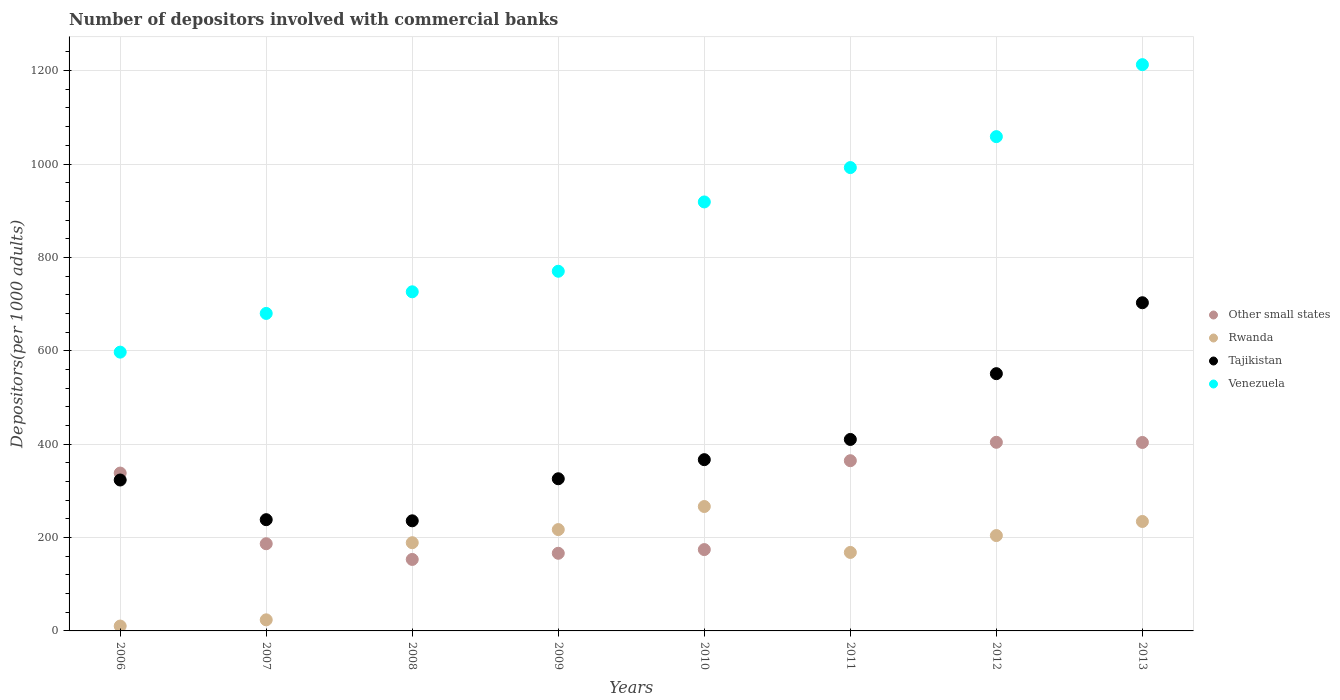Is the number of dotlines equal to the number of legend labels?
Your answer should be compact. Yes. What is the number of depositors involved with commercial banks in Tajikistan in 2009?
Ensure brevity in your answer.  325.89. Across all years, what is the maximum number of depositors involved with commercial banks in Tajikistan?
Give a very brief answer. 702.89. Across all years, what is the minimum number of depositors involved with commercial banks in Other small states?
Give a very brief answer. 153.11. In which year was the number of depositors involved with commercial banks in Venezuela maximum?
Give a very brief answer. 2013. In which year was the number of depositors involved with commercial banks in Venezuela minimum?
Your response must be concise. 2006. What is the total number of depositors involved with commercial banks in Other small states in the graph?
Make the answer very short. 2190.67. What is the difference between the number of depositors involved with commercial banks in Tajikistan in 2008 and that in 2010?
Make the answer very short. -130.97. What is the difference between the number of depositors involved with commercial banks in Other small states in 2010 and the number of depositors involved with commercial banks in Tajikistan in 2009?
Make the answer very short. -151.68. What is the average number of depositors involved with commercial banks in Other small states per year?
Give a very brief answer. 273.83. In the year 2013, what is the difference between the number of depositors involved with commercial banks in Rwanda and number of depositors involved with commercial banks in Venezuela?
Offer a very short reply. -978.43. In how many years, is the number of depositors involved with commercial banks in Other small states greater than 480?
Give a very brief answer. 0. What is the ratio of the number of depositors involved with commercial banks in Rwanda in 2006 to that in 2008?
Keep it short and to the point. 0.06. Is the number of depositors involved with commercial banks in Other small states in 2007 less than that in 2009?
Keep it short and to the point. No. Is the difference between the number of depositors involved with commercial banks in Rwanda in 2008 and 2012 greater than the difference between the number of depositors involved with commercial banks in Venezuela in 2008 and 2012?
Keep it short and to the point. Yes. What is the difference between the highest and the second highest number of depositors involved with commercial banks in Venezuela?
Your answer should be compact. 154.19. What is the difference between the highest and the lowest number of depositors involved with commercial banks in Other small states?
Make the answer very short. 250.91. In how many years, is the number of depositors involved with commercial banks in Other small states greater than the average number of depositors involved with commercial banks in Other small states taken over all years?
Offer a very short reply. 4. Is the sum of the number of depositors involved with commercial banks in Rwanda in 2009 and 2011 greater than the maximum number of depositors involved with commercial banks in Venezuela across all years?
Your response must be concise. No. Is it the case that in every year, the sum of the number of depositors involved with commercial banks in Rwanda and number of depositors involved with commercial banks in Other small states  is greater than the number of depositors involved with commercial banks in Venezuela?
Ensure brevity in your answer.  No. Is the number of depositors involved with commercial banks in Other small states strictly less than the number of depositors involved with commercial banks in Rwanda over the years?
Offer a very short reply. No. How many dotlines are there?
Provide a short and direct response. 4. Does the graph contain any zero values?
Offer a very short reply. No. Where does the legend appear in the graph?
Your response must be concise. Center right. How many legend labels are there?
Make the answer very short. 4. What is the title of the graph?
Your response must be concise. Number of depositors involved with commercial banks. Does "France" appear as one of the legend labels in the graph?
Your answer should be very brief. No. What is the label or title of the Y-axis?
Offer a very short reply. Depositors(per 1000 adults). What is the Depositors(per 1000 adults) in Other small states in 2006?
Offer a terse response. 338.08. What is the Depositors(per 1000 adults) in Rwanda in 2006?
Make the answer very short. 10.43. What is the Depositors(per 1000 adults) in Tajikistan in 2006?
Offer a terse response. 323.23. What is the Depositors(per 1000 adults) in Venezuela in 2006?
Provide a succinct answer. 597.09. What is the Depositors(per 1000 adults) in Other small states in 2007?
Provide a succinct answer. 186.74. What is the Depositors(per 1000 adults) in Rwanda in 2007?
Your answer should be very brief. 23.75. What is the Depositors(per 1000 adults) in Tajikistan in 2007?
Offer a terse response. 238.26. What is the Depositors(per 1000 adults) of Venezuela in 2007?
Your answer should be very brief. 679.99. What is the Depositors(per 1000 adults) in Other small states in 2008?
Your answer should be compact. 153.11. What is the Depositors(per 1000 adults) of Rwanda in 2008?
Give a very brief answer. 188.93. What is the Depositors(per 1000 adults) of Tajikistan in 2008?
Offer a terse response. 235.83. What is the Depositors(per 1000 adults) of Venezuela in 2008?
Provide a succinct answer. 726.32. What is the Depositors(per 1000 adults) in Other small states in 2009?
Your answer should be compact. 166.31. What is the Depositors(per 1000 adults) in Rwanda in 2009?
Provide a short and direct response. 217.05. What is the Depositors(per 1000 adults) of Tajikistan in 2009?
Offer a very short reply. 325.89. What is the Depositors(per 1000 adults) in Venezuela in 2009?
Give a very brief answer. 770.33. What is the Depositors(per 1000 adults) of Other small states in 2010?
Ensure brevity in your answer.  174.21. What is the Depositors(per 1000 adults) in Rwanda in 2010?
Your answer should be compact. 266.46. What is the Depositors(per 1000 adults) of Tajikistan in 2010?
Provide a succinct answer. 366.8. What is the Depositors(per 1000 adults) of Venezuela in 2010?
Provide a succinct answer. 918.79. What is the Depositors(per 1000 adults) in Other small states in 2011?
Your answer should be compact. 364.57. What is the Depositors(per 1000 adults) of Rwanda in 2011?
Provide a succinct answer. 168.11. What is the Depositors(per 1000 adults) of Tajikistan in 2011?
Offer a very short reply. 410.1. What is the Depositors(per 1000 adults) of Venezuela in 2011?
Keep it short and to the point. 992.39. What is the Depositors(per 1000 adults) of Other small states in 2012?
Ensure brevity in your answer.  404.02. What is the Depositors(per 1000 adults) of Rwanda in 2012?
Your answer should be compact. 204.22. What is the Depositors(per 1000 adults) in Tajikistan in 2012?
Provide a short and direct response. 550.99. What is the Depositors(per 1000 adults) of Venezuela in 2012?
Provide a succinct answer. 1058.65. What is the Depositors(per 1000 adults) in Other small states in 2013?
Your response must be concise. 403.64. What is the Depositors(per 1000 adults) in Rwanda in 2013?
Ensure brevity in your answer.  234.42. What is the Depositors(per 1000 adults) in Tajikistan in 2013?
Offer a very short reply. 702.89. What is the Depositors(per 1000 adults) in Venezuela in 2013?
Your response must be concise. 1212.85. Across all years, what is the maximum Depositors(per 1000 adults) in Other small states?
Your answer should be very brief. 404.02. Across all years, what is the maximum Depositors(per 1000 adults) of Rwanda?
Provide a short and direct response. 266.46. Across all years, what is the maximum Depositors(per 1000 adults) in Tajikistan?
Make the answer very short. 702.89. Across all years, what is the maximum Depositors(per 1000 adults) of Venezuela?
Give a very brief answer. 1212.85. Across all years, what is the minimum Depositors(per 1000 adults) in Other small states?
Keep it short and to the point. 153.11. Across all years, what is the minimum Depositors(per 1000 adults) in Rwanda?
Keep it short and to the point. 10.43. Across all years, what is the minimum Depositors(per 1000 adults) of Tajikistan?
Your response must be concise. 235.83. Across all years, what is the minimum Depositors(per 1000 adults) of Venezuela?
Keep it short and to the point. 597.09. What is the total Depositors(per 1000 adults) of Other small states in the graph?
Provide a short and direct response. 2190.67. What is the total Depositors(per 1000 adults) of Rwanda in the graph?
Your answer should be compact. 1313.36. What is the total Depositors(per 1000 adults) in Tajikistan in the graph?
Keep it short and to the point. 3153.99. What is the total Depositors(per 1000 adults) of Venezuela in the graph?
Provide a short and direct response. 6956.41. What is the difference between the Depositors(per 1000 adults) of Other small states in 2006 and that in 2007?
Your answer should be very brief. 151.33. What is the difference between the Depositors(per 1000 adults) of Rwanda in 2006 and that in 2007?
Your answer should be very brief. -13.32. What is the difference between the Depositors(per 1000 adults) in Tajikistan in 2006 and that in 2007?
Ensure brevity in your answer.  84.98. What is the difference between the Depositors(per 1000 adults) of Venezuela in 2006 and that in 2007?
Give a very brief answer. -82.9. What is the difference between the Depositors(per 1000 adults) of Other small states in 2006 and that in 2008?
Ensure brevity in your answer.  184.97. What is the difference between the Depositors(per 1000 adults) of Rwanda in 2006 and that in 2008?
Ensure brevity in your answer.  -178.5. What is the difference between the Depositors(per 1000 adults) of Tajikistan in 2006 and that in 2008?
Your answer should be very brief. 87.4. What is the difference between the Depositors(per 1000 adults) in Venezuela in 2006 and that in 2008?
Offer a very short reply. -129.23. What is the difference between the Depositors(per 1000 adults) of Other small states in 2006 and that in 2009?
Your answer should be compact. 171.77. What is the difference between the Depositors(per 1000 adults) in Rwanda in 2006 and that in 2009?
Make the answer very short. -206.62. What is the difference between the Depositors(per 1000 adults) in Tajikistan in 2006 and that in 2009?
Your answer should be very brief. -2.66. What is the difference between the Depositors(per 1000 adults) of Venezuela in 2006 and that in 2009?
Provide a short and direct response. -173.24. What is the difference between the Depositors(per 1000 adults) in Other small states in 2006 and that in 2010?
Give a very brief answer. 163.86. What is the difference between the Depositors(per 1000 adults) in Rwanda in 2006 and that in 2010?
Offer a very short reply. -256.03. What is the difference between the Depositors(per 1000 adults) of Tajikistan in 2006 and that in 2010?
Make the answer very short. -43.56. What is the difference between the Depositors(per 1000 adults) in Venezuela in 2006 and that in 2010?
Keep it short and to the point. -321.7. What is the difference between the Depositors(per 1000 adults) of Other small states in 2006 and that in 2011?
Provide a short and direct response. -26.49. What is the difference between the Depositors(per 1000 adults) of Rwanda in 2006 and that in 2011?
Your response must be concise. -157.68. What is the difference between the Depositors(per 1000 adults) of Tajikistan in 2006 and that in 2011?
Keep it short and to the point. -86.87. What is the difference between the Depositors(per 1000 adults) of Venezuela in 2006 and that in 2011?
Your response must be concise. -395.3. What is the difference between the Depositors(per 1000 adults) in Other small states in 2006 and that in 2012?
Provide a succinct answer. -65.94. What is the difference between the Depositors(per 1000 adults) in Rwanda in 2006 and that in 2012?
Your answer should be compact. -193.79. What is the difference between the Depositors(per 1000 adults) of Tajikistan in 2006 and that in 2012?
Your answer should be compact. -227.76. What is the difference between the Depositors(per 1000 adults) in Venezuela in 2006 and that in 2012?
Give a very brief answer. -461.56. What is the difference between the Depositors(per 1000 adults) in Other small states in 2006 and that in 2013?
Your answer should be compact. -65.56. What is the difference between the Depositors(per 1000 adults) of Rwanda in 2006 and that in 2013?
Your response must be concise. -223.99. What is the difference between the Depositors(per 1000 adults) in Tajikistan in 2006 and that in 2013?
Your answer should be compact. -379.66. What is the difference between the Depositors(per 1000 adults) in Venezuela in 2006 and that in 2013?
Your answer should be very brief. -615.75. What is the difference between the Depositors(per 1000 adults) of Other small states in 2007 and that in 2008?
Give a very brief answer. 33.63. What is the difference between the Depositors(per 1000 adults) in Rwanda in 2007 and that in 2008?
Provide a short and direct response. -165.19. What is the difference between the Depositors(per 1000 adults) of Tajikistan in 2007 and that in 2008?
Offer a terse response. 2.43. What is the difference between the Depositors(per 1000 adults) of Venezuela in 2007 and that in 2008?
Provide a succinct answer. -46.33. What is the difference between the Depositors(per 1000 adults) in Other small states in 2007 and that in 2009?
Give a very brief answer. 20.43. What is the difference between the Depositors(per 1000 adults) in Rwanda in 2007 and that in 2009?
Your answer should be very brief. -193.3. What is the difference between the Depositors(per 1000 adults) of Tajikistan in 2007 and that in 2009?
Offer a very short reply. -87.64. What is the difference between the Depositors(per 1000 adults) in Venezuela in 2007 and that in 2009?
Your answer should be compact. -90.34. What is the difference between the Depositors(per 1000 adults) in Other small states in 2007 and that in 2010?
Offer a terse response. 12.53. What is the difference between the Depositors(per 1000 adults) in Rwanda in 2007 and that in 2010?
Ensure brevity in your answer.  -242.71. What is the difference between the Depositors(per 1000 adults) in Tajikistan in 2007 and that in 2010?
Provide a short and direct response. -128.54. What is the difference between the Depositors(per 1000 adults) in Venezuela in 2007 and that in 2010?
Your response must be concise. -238.8. What is the difference between the Depositors(per 1000 adults) of Other small states in 2007 and that in 2011?
Provide a short and direct response. -177.83. What is the difference between the Depositors(per 1000 adults) in Rwanda in 2007 and that in 2011?
Provide a short and direct response. -144.36. What is the difference between the Depositors(per 1000 adults) in Tajikistan in 2007 and that in 2011?
Your answer should be very brief. -171.84. What is the difference between the Depositors(per 1000 adults) of Venezuela in 2007 and that in 2011?
Provide a short and direct response. -312.4. What is the difference between the Depositors(per 1000 adults) in Other small states in 2007 and that in 2012?
Your answer should be compact. -217.28. What is the difference between the Depositors(per 1000 adults) in Rwanda in 2007 and that in 2012?
Give a very brief answer. -180.47. What is the difference between the Depositors(per 1000 adults) in Tajikistan in 2007 and that in 2012?
Your answer should be compact. -312.74. What is the difference between the Depositors(per 1000 adults) of Venezuela in 2007 and that in 2012?
Give a very brief answer. -378.66. What is the difference between the Depositors(per 1000 adults) of Other small states in 2007 and that in 2013?
Make the answer very short. -216.9. What is the difference between the Depositors(per 1000 adults) of Rwanda in 2007 and that in 2013?
Your answer should be compact. -210.67. What is the difference between the Depositors(per 1000 adults) of Tajikistan in 2007 and that in 2013?
Give a very brief answer. -464.63. What is the difference between the Depositors(per 1000 adults) in Venezuela in 2007 and that in 2013?
Provide a short and direct response. -532.85. What is the difference between the Depositors(per 1000 adults) of Other small states in 2008 and that in 2009?
Make the answer very short. -13.2. What is the difference between the Depositors(per 1000 adults) in Rwanda in 2008 and that in 2009?
Provide a succinct answer. -28.11. What is the difference between the Depositors(per 1000 adults) of Tajikistan in 2008 and that in 2009?
Offer a terse response. -90.06. What is the difference between the Depositors(per 1000 adults) in Venezuela in 2008 and that in 2009?
Ensure brevity in your answer.  -44.02. What is the difference between the Depositors(per 1000 adults) in Other small states in 2008 and that in 2010?
Ensure brevity in your answer.  -21.11. What is the difference between the Depositors(per 1000 adults) in Rwanda in 2008 and that in 2010?
Offer a terse response. -77.52. What is the difference between the Depositors(per 1000 adults) in Tajikistan in 2008 and that in 2010?
Keep it short and to the point. -130.97. What is the difference between the Depositors(per 1000 adults) of Venezuela in 2008 and that in 2010?
Your answer should be compact. -192.47. What is the difference between the Depositors(per 1000 adults) of Other small states in 2008 and that in 2011?
Make the answer very short. -211.46. What is the difference between the Depositors(per 1000 adults) in Rwanda in 2008 and that in 2011?
Give a very brief answer. 20.82. What is the difference between the Depositors(per 1000 adults) of Tajikistan in 2008 and that in 2011?
Offer a very short reply. -174.27. What is the difference between the Depositors(per 1000 adults) of Venezuela in 2008 and that in 2011?
Your answer should be very brief. -266.07. What is the difference between the Depositors(per 1000 adults) of Other small states in 2008 and that in 2012?
Your response must be concise. -250.91. What is the difference between the Depositors(per 1000 adults) of Rwanda in 2008 and that in 2012?
Your answer should be compact. -15.28. What is the difference between the Depositors(per 1000 adults) in Tajikistan in 2008 and that in 2012?
Give a very brief answer. -315.16. What is the difference between the Depositors(per 1000 adults) in Venezuela in 2008 and that in 2012?
Give a very brief answer. -332.33. What is the difference between the Depositors(per 1000 adults) of Other small states in 2008 and that in 2013?
Provide a succinct answer. -250.53. What is the difference between the Depositors(per 1000 adults) of Rwanda in 2008 and that in 2013?
Your answer should be compact. -45.48. What is the difference between the Depositors(per 1000 adults) of Tajikistan in 2008 and that in 2013?
Give a very brief answer. -467.06. What is the difference between the Depositors(per 1000 adults) in Venezuela in 2008 and that in 2013?
Your response must be concise. -486.53. What is the difference between the Depositors(per 1000 adults) in Other small states in 2009 and that in 2010?
Provide a succinct answer. -7.91. What is the difference between the Depositors(per 1000 adults) in Rwanda in 2009 and that in 2010?
Provide a short and direct response. -49.41. What is the difference between the Depositors(per 1000 adults) of Tajikistan in 2009 and that in 2010?
Give a very brief answer. -40.9. What is the difference between the Depositors(per 1000 adults) in Venezuela in 2009 and that in 2010?
Provide a succinct answer. -148.45. What is the difference between the Depositors(per 1000 adults) of Other small states in 2009 and that in 2011?
Ensure brevity in your answer.  -198.26. What is the difference between the Depositors(per 1000 adults) in Rwanda in 2009 and that in 2011?
Give a very brief answer. 48.94. What is the difference between the Depositors(per 1000 adults) in Tajikistan in 2009 and that in 2011?
Offer a terse response. -84.21. What is the difference between the Depositors(per 1000 adults) in Venezuela in 2009 and that in 2011?
Your response must be concise. -222.05. What is the difference between the Depositors(per 1000 adults) in Other small states in 2009 and that in 2012?
Offer a terse response. -237.71. What is the difference between the Depositors(per 1000 adults) in Rwanda in 2009 and that in 2012?
Keep it short and to the point. 12.83. What is the difference between the Depositors(per 1000 adults) of Tajikistan in 2009 and that in 2012?
Ensure brevity in your answer.  -225.1. What is the difference between the Depositors(per 1000 adults) of Venezuela in 2009 and that in 2012?
Provide a succinct answer. -288.32. What is the difference between the Depositors(per 1000 adults) in Other small states in 2009 and that in 2013?
Provide a short and direct response. -237.33. What is the difference between the Depositors(per 1000 adults) of Rwanda in 2009 and that in 2013?
Provide a succinct answer. -17.37. What is the difference between the Depositors(per 1000 adults) in Tajikistan in 2009 and that in 2013?
Provide a short and direct response. -377. What is the difference between the Depositors(per 1000 adults) of Venezuela in 2009 and that in 2013?
Your answer should be very brief. -442.51. What is the difference between the Depositors(per 1000 adults) in Other small states in 2010 and that in 2011?
Give a very brief answer. -190.35. What is the difference between the Depositors(per 1000 adults) of Rwanda in 2010 and that in 2011?
Give a very brief answer. 98.35. What is the difference between the Depositors(per 1000 adults) in Tajikistan in 2010 and that in 2011?
Your answer should be compact. -43.3. What is the difference between the Depositors(per 1000 adults) in Venezuela in 2010 and that in 2011?
Provide a short and direct response. -73.6. What is the difference between the Depositors(per 1000 adults) of Other small states in 2010 and that in 2012?
Provide a succinct answer. -229.8. What is the difference between the Depositors(per 1000 adults) of Rwanda in 2010 and that in 2012?
Your answer should be compact. 62.24. What is the difference between the Depositors(per 1000 adults) of Tajikistan in 2010 and that in 2012?
Make the answer very short. -184.2. What is the difference between the Depositors(per 1000 adults) in Venezuela in 2010 and that in 2012?
Make the answer very short. -139.86. What is the difference between the Depositors(per 1000 adults) of Other small states in 2010 and that in 2013?
Provide a succinct answer. -229.42. What is the difference between the Depositors(per 1000 adults) of Rwanda in 2010 and that in 2013?
Offer a terse response. 32.04. What is the difference between the Depositors(per 1000 adults) of Tajikistan in 2010 and that in 2013?
Keep it short and to the point. -336.09. What is the difference between the Depositors(per 1000 adults) in Venezuela in 2010 and that in 2013?
Make the answer very short. -294.06. What is the difference between the Depositors(per 1000 adults) in Other small states in 2011 and that in 2012?
Provide a short and direct response. -39.45. What is the difference between the Depositors(per 1000 adults) in Rwanda in 2011 and that in 2012?
Provide a short and direct response. -36.1. What is the difference between the Depositors(per 1000 adults) in Tajikistan in 2011 and that in 2012?
Make the answer very short. -140.89. What is the difference between the Depositors(per 1000 adults) in Venezuela in 2011 and that in 2012?
Provide a short and direct response. -66.26. What is the difference between the Depositors(per 1000 adults) of Other small states in 2011 and that in 2013?
Provide a succinct answer. -39.07. What is the difference between the Depositors(per 1000 adults) of Rwanda in 2011 and that in 2013?
Offer a terse response. -66.31. What is the difference between the Depositors(per 1000 adults) of Tajikistan in 2011 and that in 2013?
Provide a succinct answer. -292.79. What is the difference between the Depositors(per 1000 adults) in Venezuela in 2011 and that in 2013?
Your answer should be compact. -220.46. What is the difference between the Depositors(per 1000 adults) in Other small states in 2012 and that in 2013?
Your answer should be very brief. 0.38. What is the difference between the Depositors(per 1000 adults) of Rwanda in 2012 and that in 2013?
Offer a terse response. -30.2. What is the difference between the Depositors(per 1000 adults) in Tajikistan in 2012 and that in 2013?
Offer a very short reply. -151.9. What is the difference between the Depositors(per 1000 adults) of Venezuela in 2012 and that in 2013?
Offer a terse response. -154.19. What is the difference between the Depositors(per 1000 adults) of Other small states in 2006 and the Depositors(per 1000 adults) of Rwanda in 2007?
Provide a succinct answer. 314.33. What is the difference between the Depositors(per 1000 adults) of Other small states in 2006 and the Depositors(per 1000 adults) of Tajikistan in 2007?
Your answer should be very brief. 99.82. What is the difference between the Depositors(per 1000 adults) in Other small states in 2006 and the Depositors(per 1000 adults) in Venezuela in 2007?
Offer a very short reply. -341.92. What is the difference between the Depositors(per 1000 adults) in Rwanda in 2006 and the Depositors(per 1000 adults) in Tajikistan in 2007?
Keep it short and to the point. -227.83. What is the difference between the Depositors(per 1000 adults) in Rwanda in 2006 and the Depositors(per 1000 adults) in Venezuela in 2007?
Offer a terse response. -669.56. What is the difference between the Depositors(per 1000 adults) in Tajikistan in 2006 and the Depositors(per 1000 adults) in Venezuela in 2007?
Your answer should be very brief. -356.76. What is the difference between the Depositors(per 1000 adults) in Other small states in 2006 and the Depositors(per 1000 adults) in Rwanda in 2008?
Offer a very short reply. 149.14. What is the difference between the Depositors(per 1000 adults) of Other small states in 2006 and the Depositors(per 1000 adults) of Tajikistan in 2008?
Keep it short and to the point. 102.25. What is the difference between the Depositors(per 1000 adults) of Other small states in 2006 and the Depositors(per 1000 adults) of Venezuela in 2008?
Offer a very short reply. -388.24. What is the difference between the Depositors(per 1000 adults) of Rwanda in 2006 and the Depositors(per 1000 adults) of Tajikistan in 2008?
Offer a terse response. -225.4. What is the difference between the Depositors(per 1000 adults) of Rwanda in 2006 and the Depositors(per 1000 adults) of Venezuela in 2008?
Ensure brevity in your answer.  -715.89. What is the difference between the Depositors(per 1000 adults) in Tajikistan in 2006 and the Depositors(per 1000 adults) in Venezuela in 2008?
Offer a very short reply. -403.09. What is the difference between the Depositors(per 1000 adults) of Other small states in 2006 and the Depositors(per 1000 adults) of Rwanda in 2009?
Provide a succinct answer. 121.03. What is the difference between the Depositors(per 1000 adults) in Other small states in 2006 and the Depositors(per 1000 adults) in Tajikistan in 2009?
Ensure brevity in your answer.  12.18. What is the difference between the Depositors(per 1000 adults) in Other small states in 2006 and the Depositors(per 1000 adults) in Venezuela in 2009?
Provide a succinct answer. -432.26. What is the difference between the Depositors(per 1000 adults) of Rwanda in 2006 and the Depositors(per 1000 adults) of Tajikistan in 2009?
Keep it short and to the point. -315.46. What is the difference between the Depositors(per 1000 adults) of Rwanda in 2006 and the Depositors(per 1000 adults) of Venezuela in 2009?
Ensure brevity in your answer.  -759.91. What is the difference between the Depositors(per 1000 adults) in Tajikistan in 2006 and the Depositors(per 1000 adults) in Venezuela in 2009?
Ensure brevity in your answer.  -447.1. What is the difference between the Depositors(per 1000 adults) in Other small states in 2006 and the Depositors(per 1000 adults) in Rwanda in 2010?
Offer a very short reply. 71.62. What is the difference between the Depositors(per 1000 adults) in Other small states in 2006 and the Depositors(per 1000 adults) in Tajikistan in 2010?
Offer a very short reply. -28.72. What is the difference between the Depositors(per 1000 adults) in Other small states in 2006 and the Depositors(per 1000 adults) in Venezuela in 2010?
Ensure brevity in your answer.  -580.71. What is the difference between the Depositors(per 1000 adults) of Rwanda in 2006 and the Depositors(per 1000 adults) of Tajikistan in 2010?
Provide a short and direct response. -356.37. What is the difference between the Depositors(per 1000 adults) of Rwanda in 2006 and the Depositors(per 1000 adults) of Venezuela in 2010?
Your answer should be compact. -908.36. What is the difference between the Depositors(per 1000 adults) of Tajikistan in 2006 and the Depositors(per 1000 adults) of Venezuela in 2010?
Ensure brevity in your answer.  -595.56. What is the difference between the Depositors(per 1000 adults) in Other small states in 2006 and the Depositors(per 1000 adults) in Rwanda in 2011?
Your answer should be compact. 169.97. What is the difference between the Depositors(per 1000 adults) of Other small states in 2006 and the Depositors(per 1000 adults) of Tajikistan in 2011?
Your answer should be very brief. -72.02. What is the difference between the Depositors(per 1000 adults) in Other small states in 2006 and the Depositors(per 1000 adults) in Venezuela in 2011?
Your answer should be very brief. -654.31. What is the difference between the Depositors(per 1000 adults) of Rwanda in 2006 and the Depositors(per 1000 adults) of Tajikistan in 2011?
Offer a terse response. -399.67. What is the difference between the Depositors(per 1000 adults) of Rwanda in 2006 and the Depositors(per 1000 adults) of Venezuela in 2011?
Give a very brief answer. -981.96. What is the difference between the Depositors(per 1000 adults) of Tajikistan in 2006 and the Depositors(per 1000 adults) of Venezuela in 2011?
Provide a succinct answer. -669.16. What is the difference between the Depositors(per 1000 adults) of Other small states in 2006 and the Depositors(per 1000 adults) of Rwanda in 2012?
Your response must be concise. 133.86. What is the difference between the Depositors(per 1000 adults) in Other small states in 2006 and the Depositors(per 1000 adults) in Tajikistan in 2012?
Offer a terse response. -212.92. What is the difference between the Depositors(per 1000 adults) in Other small states in 2006 and the Depositors(per 1000 adults) in Venezuela in 2012?
Ensure brevity in your answer.  -720.58. What is the difference between the Depositors(per 1000 adults) of Rwanda in 2006 and the Depositors(per 1000 adults) of Tajikistan in 2012?
Offer a terse response. -540.56. What is the difference between the Depositors(per 1000 adults) in Rwanda in 2006 and the Depositors(per 1000 adults) in Venezuela in 2012?
Make the answer very short. -1048.22. What is the difference between the Depositors(per 1000 adults) in Tajikistan in 2006 and the Depositors(per 1000 adults) in Venezuela in 2012?
Ensure brevity in your answer.  -735.42. What is the difference between the Depositors(per 1000 adults) of Other small states in 2006 and the Depositors(per 1000 adults) of Rwanda in 2013?
Your answer should be very brief. 103.66. What is the difference between the Depositors(per 1000 adults) in Other small states in 2006 and the Depositors(per 1000 adults) in Tajikistan in 2013?
Offer a terse response. -364.81. What is the difference between the Depositors(per 1000 adults) in Other small states in 2006 and the Depositors(per 1000 adults) in Venezuela in 2013?
Offer a terse response. -874.77. What is the difference between the Depositors(per 1000 adults) of Rwanda in 2006 and the Depositors(per 1000 adults) of Tajikistan in 2013?
Offer a very short reply. -692.46. What is the difference between the Depositors(per 1000 adults) of Rwanda in 2006 and the Depositors(per 1000 adults) of Venezuela in 2013?
Give a very brief answer. -1202.42. What is the difference between the Depositors(per 1000 adults) in Tajikistan in 2006 and the Depositors(per 1000 adults) in Venezuela in 2013?
Ensure brevity in your answer.  -889.61. What is the difference between the Depositors(per 1000 adults) of Other small states in 2007 and the Depositors(per 1000 adults) of Rwanda in 2008?
Your answer should be very brief. -2.19. What is the difference between the Depositors(per 1000 adults) of Other small states in 2007 and the Depositors(per 1000 adults) of Tajikistan in 2008?
Your answer should be compact. -49.09. What is the difference between the Depositors(per 1000 adults) in Other small states in 2007 and the Depositors(per 1000 adults) in Venezuela in 2008?
Give a very brief answer. -539.58. What is the difference between the Depositors(per 1000 adults) of Rwanda in 2007 and the Depositors(per 1000 adults) of Tajikistan in 2008?
Provide a short and direct response. -212.08. What is the difference between the Depositors(per 1000 adults) in Rwanda in 2007 and the Depositors(per 1000 adults) in Venezuela in 2008?
Your response must be concise. -702.57. What is the difference between the Depositors(per 1000 adults) of Tajikistan in 2007 and the Depositors(per 1000 adults) of Venezuela in 2008?
Provide a short and direct response. -488.06. What is the difference between the Depositors(per 1000 adults) of Other small states in 2007 and the Depositors(per 1000 adults) of Rwanda in 2009?
Your answer should be compact. -30.3. What is the difference between the Depositors(per 1000 adults) of Other small states in 2007 and the Depositors(per 1000 adults) of Tajikistan in 2009?
Provide a succinct answer. -139.15. What is the difference between the Depositors(per 1000 adults) of Other small states in 2007 and the Depositors(per 1000 adults) of Venezuela in 2009?
Make the answer very short. -583.59. What is the difference between the Depositors(per 1000 adults) of Rwanda in 2007 and the Depositors(per 1000 adults) of Tajikistan in 2009?
Offer a very short reply. -302.14. What is the difference between the Depositors(per 1000 adults) of Rwanda in 2007 and the Depositors(per 1000 adults) of Venezuela in 2009?
Offer a terse response. -746.59. What is the difference between the Depositors(per 1000 adults) of Tajikistan in 2007 and the Depositors(per 1000 adults) of Venezuela in 2009?
Your response must be concise. -532.08. What is the difference between the Depositors(per 1000 adults) in Other small states in 2007 and the Depositors(per 1000 adults) in Rwanda in 2010?
Your answer should be compact. -79.72. What is the difference between the Depositors(per 1000 adults) of Other small states in 2007 and the Depositors(per 1000 adults) of Tajikistan in 2010?
Your response must be concise. -180.06. What is the difference between the Depositors(per 1000 adults) in Other small states in 2007 and the Depositors(per 1000 adults) in Venezuela in 2010?
Offer a very short reply. -732.05. What is the difference between the Depositors(per 1000 adults) of Rwanda in 2007 and the Depositors(per 1000 adults) of Tajikistan in 2010?
Ensure brevity in your answer.  -343.05. What is the difference between the Depositors(per 1000 adults) of Rwanda in 2007 and the Depositors(per 1000 adults) of Venezuela in 2010?
Make the answer very short. -895.04. What is the difference between the Depositors(per 1000 adults) of Tajikistan in 2007 and the Depositors(per 1000 adults) of Venezuela in 2010?
Make the answer very short. -680.53. What is the difference between the Depositors(per 1000 adults) of Other small states in 2007 and the Depositors(per 1000 adults) of Rwanda in 2011?
Your answer should be compact. 18.63. What is the difference between the Depositors(per 1000 adults) in Other small states in 2007 and the Depositors(per 1000 adults) in Tajikistan in 2011?
Your response must be concise. -223.36. What is the difference between the Depositors(per 1000 adults) in Other small states in 2007 and the Depositors(per 1000 adults) in Venezuela in 2011?
Provide a succinct answer. -805.65. What is the difference between the Depositors(per 1000 adults) in Rwanda in 2007 and the Depositors(per 1000 adults) in Tajikistan in 2011?
Provide a succinct answer. -386.35. What is the difference between the Depositors(per 1000 adults) of Rwanda in 2007 and the Depositors(per 1000 adults) of Venezuela in 2011?
Keep it short and to the point. -968.64. What is the difference between the Depositors(per 1000 adults) of Tajikistan in 2007 and the Depositors(per 1000 adults) of Venezuela in 2011?
Your response must be concise. -754.13. What is the difference between the Depositors(per 1000 adults) in Other small states in 2007 and the Depositors(per 1000 adults) in Rwanda in 2012?
Provide a succinct answer. -17.47. What is the difference between the Depositors(per 1000 adults) of Other small states in 2007 and the Depositors(per 1000 adults) of Tajikistan in 2012?
Your answer should be compact. -364.25. What is the difference between the Depositors(per 1000 adults) of Other small states in 2007 and the Depositors(per 1000 adults) of Venezuela in 2012?
Your answer should be compact. -871.91. What is the difference between the Depositors(per 1000 adults) in Rwanda in 2007 and the Depositors(per 1000 adults) in Tajikistan in 2012?
Your response must be concise. -527.24. What is the difference between the Depositors(per 1000 adults) of Rwanda in 2007 and the Depositors(per 1000 adults) of Venezuela in 2012?
Offer a very short reply. -1034.9. What is the difference between the Depositors(per 1000 adults) in Tajikistan in 2007 and the Depositors(per 1000 adults) in Venezuela in 2012?
Provide a short and direct response. -820.39. What is the difference between the Depositors(per 1000 adults) in Other small states in 2007 and the Depositors(per 1000 adults) in Rwanda in 2013?
Your response must be concise. -47.68. What is the difference between the Depositors(per 1000 adults) of Other small states in 2007 and the Depositors(per 1000 adults) of Tajikistan in 2013?
Give a very brief answer. -516.15. What is the difference between the Depositors(per 1000 adults) in Other small states in 2007 and the Depositors(per 1000 adults) in Venezuela in 2013?
Provide a short and direct response. -1026.1. What is the difference between the Depositors(per 1000 adults) in Rwanda in 2007 and the Depositors(per 1000 adults) in Tajikistan in 2013?
Ensure brevity in your answer.  -679.14. What is the difference between the Depositors(per 1000 adults) in Rwanda in 2007 and the Depositors(per 1000 adults) in Venezuela in 2013?
Offer a terse response. -1189.1. What is the difference between the Depositors(per 1000 adults) in Tajikistan in 2007 and the Depositors(per 1000 adults) in Venezuela in 2013?
Ensure brevity in your answer.  -974.59. What is the difference between the Depositors(per 1000 adults) in Other small states in 2008 and the Depositors(per 1000 adults) in Rwanda in 2009?
Your response must be concise. -63.94. What is the difference between the Depositors(per 1000 adults) in Other small states in 2008 and the Depositors(per 1000 adults) in Tajikistan in 2009?
Provide a succinct answer. -172.79. What is the difference between the Depositors(per 1000 adults) of Other small states in 2008 and the Depositors(per 1000 adults) of Venezuela in 2009?
Offer a very short reply. -617.23. What is the difference between the Depositors(per 1000 adults) of Rwanda in 2008 and the Depositors(per 1000 adults) of Tajikistan in 2009?
Offer a very short reply. -136.96. What is the difference between the Depositors(per 1000 adults) of Rwanda in 2008 and the Depositors(per 1000 adults) of Venezuela in 2009?
Your answer should be compact. -581.4. What is the difference between the Depositors(per 1000 adults) in Tajikistan in 2008 and the Depositors(per 1000 adults) in Venezuela in 2009?
Make the answer very short. -534.51. What is the difference between the Depositors(per 1000 adults) of Other small states in 2008 and the Depositors(per 1000 adults) of Rwanda in 2010?
Provide a short and direct response. -113.35. What is the difference between the Depositors(per 1000 adults) in Other small states in 2008 and the Depositors(per 1000 adults) in Tajikistan in 2010?
Your response must be concise. -213.69. What is the difference between the Depositors(per 1000 adults) of Other small states in 2008 and the Depositors(per 1000 adults) of Venezuela in 2010?
Give a very brief answer. -765.68. What is the difference between the Depositors(per 1000 adults) of Rwanda in 2008 and the Depositors(per 1000 adults) of Tajikistan in 2010?
Your answer should be very brief. -177.86. What is the difference between the Depositors(per 1000 adults) of Rwanda in 2008 and the Depositors(per 1000 adults) of Venezuela in 2010?
Keep it short and to the point. -729.85. What is the difference between the Depositors(per 1000 adults) of Tajikistan in 2008 and the Depositors(per 1000 adults) of Venezuela in 2010?
Keep it short and to the point. -682.96. What is the difference between the Depositors(per 1000 adults) of Other small states in 2008 and the Depositors(per 1000 adults) of Rwanda in 2011?
Offer a terse response. -15. What is the difference between the Depositors(per 1000 adults) of Other small states in 2008 and the Depositors(per 1000 adults) of Tajikistan in 2011?
Make the answer very short. -256.99. What is the difference between the Depositors(per 1000 adults) in Other small states in 2008 and the Depositors(per 1000 adults) in Venezuela in 2011?
Offer a very short reply. -839.28. What is the difference between the Depositors(per 1000 adults) in Rwanda in 2008 and the Depositors(per 1000 adults) in Tajikistan in 2011?
Offer a terse response. -221.16. What is the difference between the Depositors(per 1000 adults) of Rwanda in 2008 and the Depositors(per 1000 adults) of Venezuela in 2011?
Your response must be concise. -803.45. What is the difference between the Depositors(per 1000 adults) of Tajikistan in 2008 and the Depositors(per 1000 adults) of Venezuela in 2011?
Offer a terse response. -756.56. What is the difference between the Depositors(per 1000 adults) of Other small states in 2008 and the Depositors(per 1000 adults) of Rwanda in 2012?
Your answer should be compact. -51.11. What is the difference between the Depositors(per 1000 adults) of Other small states in 2008 and the Depositors(per 1000 adults) of Tajikistan in 2012?
Make the answer very short. -397.89. What is the difference between the Depositors(per 1000 adults) of Other small states in 2008 and the Depositors(per 1000 adults) of Venezuela in 2012?
Your answer should be compact. -905.55. What is the difference between the Depositors(per 1000 adults) in Rwanda in 2008 and the Depositors(per 1000 adults) in Tajikistan in 2012?
Your answer should be very brief. -362.06. What is the difference between the Depositors(per 1000 adults) of Rwanda in 2008 and the Depositors(per 1000 adults) of Venezuela in 2012?
Ensure brevity in your answer.  -869.72. What is the difference between the Depositors(per 1000 adults) of Tajikistan in 2008 and the Depositors(per 1000 adults) of Venezuela in 2012?
Provide a succinct answer. -822.82. What is the difference between the Depositors(per 1000 adults) of Other small states in 2008 and the Depositors(per 1000 adults) of Rwanda in 2013?
Your answer should be very brief. -81.31. What is the difference between the Depositors(per 1000 adults) of Other small states in 2008 and the Depositors(per 1000 adults) of Tajikistan in 2013?
Your answer should be compact. -549.78. What is the difference between the Depositors(per 1000 adults) of Other small states in 2008 and the Depositors(per 1000 adults) of Venezuela in 2013?
Give a very brief answer. -1059.74. What is the difference between the Depositors(per 1000 adults) of Rwanda in 2008 and the Depositors(per 1000 adults) of Tajikistan in 2013?
Keep it short and to the point. -513.96. What is the difference between the Depositors(per 1000 adults) of Rwanda in 2008 and the Depositors(per 1000 adults) of Venezuela in 2013?
Offer a very short reply. -1023.91. What is the difference between the Depositors(per 1000 adults) in Tajikistan in 2008 and the Depositors(per 1000 adults) in Venezuela in 2013?
Make the answer very short. -977.02. What is the difference between the Depositors(per 1000 adults) in Other small states in 2009 and the Depositors(per 1000 adults) in Rwanda in 2010?
Provide a succinct answer. -100.15. What is the difference between the Depositors(per 1000 adults) of Other small states in 2009 and the Depositors(per 1000 adults) of Tajikistan in 2010?
Keep it short and to the point. -200.49. What is the difference between the Depositors(per 1000 adults) of Other small states in 2009 and the Depositors(per 1000 adults) of Venezuela in 2010?
Provide a succinct answer. -752.48. What is the difference between the Depositors(per 1000 adults) in Rwanda in 2009 and the Depositors(per 1000 adults) in Tajikistan in 2010?
Offer a very short reply. -149.75. What is the difference between the Depositors(per 1000 adults) in Rwanda in 2009 and the Depositors(per 1000 adults) in Venezuela in 2010?
Your answer should be compact. -701.74. What is the difference between the Depositors(per 1000 adults) of Tajikistan in 2009 and the Depositors(per 1000 adults) of Venezuela in 2010?
Your response must be concise. -592.9. What is the difference between the Depositors(per 1000 adults) of Other small states in 2009 and the Depositors(per 1000 adults) of Rwanda in 2011?
Offer a very short reply. -1.8. What is the difference between the Depositors(per 1000 adults) of Other small states in 2009 and the Depositors(per 1000 adults) of Tajikistan in 2011?
Provide a succinct answer. -243.79. What is the difference between the Depositors(per 1000 adults) in Other small states in 2009 and the Depositors(per 1000 adults) in Venezuela in 2011?
Your response must be concise. -826.08. What is the difference between the Depositors(per 1000 adults) of Rwanda in 2009 and the Depositors(per 1000 adults) of Tajikistan in 2011?
Provide a succinct answer. -193.05. What is the difference between the Depositors(per 1000 adults) of Rwanda in 2009 and the Depositors(per 1000 adults) of Venezuela in 2011?
Offer a very short reply. -775.34. What is the difference between the Depositors(per 1000 adults) in Tajikistan in 2009 and the Depositors(per 1000 adults) in Venezuela in 2011?
Offer a terse response. -666.5. What is the difference between the Depositors(per 1000 adults) in Other small states in 2009 and the Depositors(per 1000 adults) in Rwanda in 2012?
Ensure brevity in your answer.  -37.91. What is the difference between the Depositors(per 1000 adults) in Other small states in 2009 and the Depositors(per 1000 adults) in Tajikistan in 2012?
Make the answer very short. -384.69. What is the difference between the Depositors(per 1000 adults) in Other small states in 2009 and the Depositors(per 1000 adults) in Venezuela in 2012?
Your answer should be compact. -892.34. What is the difference between the Depositors(per 1000 adults) of Rwanda in 2009 and the Depositors(per 1000 adults) of Tajikistan in 2012?
Your answer should be very brief. -333.95. What is the difference between the Depositors(per 1000 adults) in Rwanda in 2009 and the Depositors(per 1000 adults) in Venezuela in 2012?
Your answer should be compact. -841.61. What is the difference between the Depositors(per 1000 adults) in Tajikistan in 2009 and the Depositors(per 1000 adults) in Venezuela in 2012?
Provide a succinct answer. -732.76. What is the difference between the Depositors(per 1000 adults) of Other small states in 2009 and the Depositors(per 1000 adults) of Rwanda in 2013?
Make the answer very short. -68.11. What is the difference between the Depositors(per 1000 adults) of Other small states in 2009 and the Depositors(per 1000 adults) of Tajikistan in 2013?
Offer a terse response. -536.58. What is the difference between the Depositors(per 1000 adults) of Other small states in 2009 and the Depositors(per 1000 adults) of Venezuela in 2013?
Give a very brief answer. -1046.54. What is the difference between the Depositors(per 1000 adults) of Rwanda in 2009 and the Depositors(per 1000 adults) of Tajikistan in 2013?
Your response must be concise. -485.84. What is the difference between the Depositors(per 1000 adults) of Rwanda in 2009 and the Depositors(per 1000 adults) of Venezuela in 2013?
Make the answer very short. -995.8. What is the difference between the Depositors(per 1000 adults) of Tajikistan in 2009 and the Depositors(per 1000 adults) of Venezuela in 2013?
Provide a succinct answer. -886.95. What is the difference between the Depositors(per 1000 adults) in Other small states in 2010 and the Depositors(per 1000 adults) in Rwanda in 2011?
Your answer should be compact. 6.1. What is the difference between the Depositors(per 1000 adults) of Other small states in 2010 and the Depositors(per 1000 adults) of Tajikistan in 2011?
Provide a short and direct response. -235.89. What is the difference between the Depositors(per 1000 adults) of Other small states in 2010 and the Depositors(per 1000 adults) of Venezuela in 2011?
Offer a very short reply. -818.17. What is the difference between the Depositors(per 1000 adults) in Rwanda in 2010 and the Depositors(per 1000 adults) in Tajikistan in 2011?
Offer a terse response. -143.64. What is the difference between the Depositors(per 1000 adults) of Rwanda in 2010 and the Depositors(per 1000 adults) of Venezuela in 2011?
Your response must be concise. -725.93. What is the difference between the Depositors(per 1000 adults) of Tajikistan in 2010 and the Depositors(per 1000 adults) of Venezuela in 2011?
Offer a very short reply. -625.59. What is the difference between the Depositors(per 1000 adults) in Other small states in 2010 and the Depositors(per 1000 adults) in Rwanda in 2012?
Keep it short and to the point. -30. What is the difference between the Depositors(per 1000 adults) in Other small states in 2010 and the Depositors(per 1000 adults) in Tajikistan in 2012?
Keep it short and to the point. -376.78. What is the difference between the Depositors(per 1000 adults) of Other small states in 2010 and the Depositors(per 1000 adults) of Venezuela in 2012?
Offer a very short reply. -884.44. What is the difference between the Depositors(per 1000 adults) in Rwanda in 2010 and the Depositors(per 1000 adults) in Tajikistan in 2012?
Offer a terse response. -284.54. What is the difference between the Depositors(per 1000 adults) of Rwanda in 2010 and the Depositors(per 1000 adults) of Venezuela in 2012?
Ensure brevity in your answer.  -792.2. What is the difference between the Depositors(per 1000 adults) in Tajikistan in 2010 and the Depositors(per 1000 adults) in Venezuela in 2012?
Your answer should be compact. -691.86. What is the difference between the Depositors(per 1000 adults) of Other small states in 2010 and the Depositors(per 1000 adults) of Rwanda in 2013?
Keep it short and to the point. -60.2. What is the difference between the Depositors(per 1000 adults) of Other small states in 2010 and the Depositors(per 1000 adults) of Tajikistan in 2013?
Offer a terse response. -528.68. What is the difference between the Depositors(per 1000 adults) in Other small states in 2010 and the Depositors(per 1000 adults) in Venezuela in 2013?
Provide a short and direct response. -1038.63. What is the difference between the Depositors(per 1000 adults) in Rwanda in 2010 and the Depositors(per 1000 adults) in Tajikistan in 2013?
Your response must be concise. -436.43. What is the difference between the Depositors(per 1000 adults) of Rwanda in 2010 and the Depositors(per 1000 adults) of Venezuela in 2013?
Provide a succinct answer. -946.39. What is the difference between the Depositors(per 1000 adults) of Tajikistan in 2010 and the Depositors(per 1000 adults) of Venezuela in 2013?
Provide a short and direct response. -846.05. What is the difference between the Depositors(per 1000 adults) of Other small states in 2011 and the Depositors(per 1000 adults) of Rwanda in 2012?
Ensure brevity in your answer.  160.35. What is the difference between the Depositors(per 1000 adults) of Other small states in 2011 and the Depositors(per 1000 adults) of Tajikistan in 2012?
Your answer should be compact. -186.42. What is the difference between the Depositors(per 1000 adults) of Other small states in 2011 and the Depositors(per 1000 adults) of Venezuela in 2012?
Ensure brevity in your answer.  -694.08. What is the difference between the Depositors(per 1000 adults) of Rwanda in 2011 and the Depositors(per 1000 adults) of Tajikistan in 2012?
Provide a succinct answer. -382.88. What is the difference between the Depositors(per 1000 adults) in Rwanda in 2011 and the Depositors(per 1000 adults) in Venezuela in 2012?
Make the answer very short. -890.54. What is the difference between the Depositors(per 1000 adults) in Tajikistan in 2011 and the Depositors(per 1000 adults) in Venezuela in 2012?
Make the answer very short. -648.55. What is the difference between the Depositors(per 1000 adults) of Other small states in 2011 and the Depositors(per 1000 adults) of Rwanda in 2013?
Give a very brief answer. 130.15. What is the difference between the Depositors(per 1000 adults) in Other small states in 2011 and the Depositors(per 1000 adults) in Tajikistan in 2013?
Ensure brevity in your answer.  -338.32. What is the difference between the Depositors(per 1000 adults) in Other small states in 2011 and the Depositors(per 1000 adults) in Venezuela in 2013?
Your response must be concise. -848.28. What is the difference between the Depositors(per 1000 adults) in Rwanda in 2011 and the Depositors(per 1000 adults) in Tajikistan in 2013?
Provide a short and direct response. -534.78. What is the difference between the Depositors(per 1000 adults) in Rwanda in 2011 and the Depositors(per 1000 adults) in Venezuela in 2013?
Give a very brief answer. -1044.73. What is the difference between the Depositors(per 1000 adults) of Tajikistan in 2011 and the Depositors(per 1000 adults) of Venezuela in 2013?
Provide a short and direct response. -802.75. What is the difference between the Depositors(per 1000 adults) in Other small states in 2012 and the Depositors(per 1000 adults) in Rwanda in 2013?
Offer a very short reply. 169.6. What is the difference between the Depositors(per 1000 adults) in Other small states in 2012 and the Depositors(per 1000 adults) in Tajikistan in 2013?
Provide a succinct answer. -298.87. What is the difference between the Depositors(per 1000 adults) in Other small states in 2012 and the Depositors(per 1000 adults) in Venezuela in 2013?
Make the answer very short. -808.83. What is the difference between the Depositors(per 1000 adults) of Rwanda in 2012 and the Depositors(per 1000 adults) of Tajikistan in 2013?
Ensure brevity in your answer.  -498.67. What is the difference between the Depositors(per 1000 adults) of Rwanda in 2012 and the Depositors(per 1000 adults) of Venezuela in 2013?
Provide a short and direct response. -1008.63. What is the difference between the Depositors(per 1000 adults) in Tajikistan in 2012 and the Depositors(per 1000 adults) in Venezuela in 2013?
Your response must be concise. -661.85. What is the average Depositors(per 1000 adults) in Other small states per year?
Ensure brevity in your answer.  273.83. What is the average Depositors(per 1000 adults) in Rwanda per year?
Your answer should be compact. 164.17. What is the average Depositors(per 1000 adults) in Tajikistan per year?
Keep it short and to the point. 394.25. What is the average Depositors(per 1000 adults) in Venezuela per year?
Make the answer very short. 869.55. In the year 2006, what is the difference between the Depositors(per 1000 adults) of Other small states and Depositors(per 1000 adults) of Rwanda?
Your answer should be very brief. 327.65. In the year 2006, what is the difference between the Depositors(per 1000 adults) of Other small states and Depositors(per 1000 adults) of Tajikistan?
Provide a succinct answer. 14.84. In the year 2006, what is the difference between the Depositors(per 1000 adults) in Other small states and Depositors(per 1000 adults) in Venezuela?
Provide a succinct answer. -259.02. In the year 2006, what is the difference between the Depositors(per 1000 adults) in Rwanda and Depositors(per 1000 adults) in Tajikistan?
Provide a short and direct response. -312.8. In the year 2006, what is the difference between the Depositors(per 1000 adults) of Rwanda and Depositors(per 1000 adults) of Venezuela?
Your response must be concise. -586.66. In the year 2006, what is the difference between the Depositors(per 1000 adults) in Tajikistan and Depositors(per 1000 adults) in Venezuela?
Keep it short and to the point. -273.86. In the year 2007, what is the difference between the Depositors(per 1000 adults) in Other small states and Depositors(per 1000 adults) in Rwanda?
Offer a terse response. 162.99. In the year 2007, what is the difference between the Depositors(per 1000 adults) in Other small states and Depositors(per 1000 adults) in Tajikistan?
Provide a short and direct response. -51.52. In the year 2007, what is the difference between the Depositors(per 1000 adults) in Other small states and Depositors(per 1000 adults) in Venezuela?
Keep it short and to the point. -493.25. In the year 2007, what is the difference between the Depositors(per 1000 adults) in Rwanda and Depositors(per 1000 adults) in Tajikistan?
Offer a very short reply. -214.51. In the year 2007, what is the difference between the Depositors(per 1000 adults) in Rwanda and Depositors(per 1000 adults) in Venezuela?
Your answer should be very brief. -656.24. In the year 2007, what is the difference between the Depositors(per 1000 adults) of Tajikistan and Depositors(per 1000 adults) of Venezuela?
Provide a succinct answer. -441.73. In the year 2008, what is the difference between the Depositors(per 1000 adults) of Other small states and Depositors(per 1000 adults) of Rwanda?
Ensure brevity in your answer.  -35.83. In the year 2008, what is the difference between the Depositors(per 1000 adults) in Other small states and Depositors(per 1000 adults) in Tajikistan?
Offer a terse response. -82.72. In the year 2008, what is the difference between the Depositors(per 1000 adults) of Other small states and Depositors(per 1000 adults) of Venezuela?
Your answer should be very brief. -573.21. In the year 2008, what is the difference between the Depositors(per 1000 adults) of Rwanda and Depositors(per 1000 adults) of Tajikistan?
Keep it short and to the point. -46.89. In the year 2008, what is the difference between the Depositors(per 1000 adults) of Rwanda and Depositors(per 1000 adults) of Venezuela?
Give a very brief answer. -537.38. In the year 2008, what is the difference between the Depositors(per 1000 adults) in Tajikistan and Depositors(per 1000 adults) in Venezuela?
Ensure brevity in your answer.  -490.49. In the year 2009, what is the difference between the Depositors(per 1000 adults) in Other small states and Depositors(per 1000 adults) in Rwanda?
Provide a succinct answer. -50.74. In the year 2009, what is the difference between the Depositors(per 1000 adults) of Other small states and Depositors(per 1000 adults) of Tajikistan?
Your answer should be compact. -159.59. In the year 2009, what is the difference between the Depositors(per 1000 adults) of Other small states and Depositors(per 1000 adults) of Venezuela?
Provide a short and direct response. -604.03. In the year 2009, what is the difference between the Depositors(per 1000 adults) in Rwanda and Depositors(per 1000 adults) in Tajikistan?
Your answer should be very brief. -108.85. In the year 2009, what is the difference between the Depositors(per 1000 adults) of Rwanda and Depositors(per 1000 adults) of Venezuela?
Your answer should be compact. -553.29. In the year 2009, what is the difference between the Depositors(per 1000 adults) of Tajikistan and Depositors(per 1000 adults) of Venezuela?
Your answer should be compact. -444.44. In the year 2010, what is the difference between the Depositors(per 1000 adults) of Other small states and Depositors(per 1000 adults) of Rwanda?
Ensure brevity in your answer.  -92.24. In the year 2010, what is the difference between the Depositors(per 1000 adults) in Other small states and Depositors(per 1000 adults) in Tajikistan?
Offer a very short reply. -192.58. In the year 2010, what is the difference between the Depositors(per 1000 adults) of Other small states and Depositors(per 1000 adults) of Venezuela?
Your response must be concise. -744.58. In the year 2010, what is the difference between the Depositors(per 1000 adults) of Rwanda and Depositors(per 1000 adults) of Tajikistan?
Your answer should be very brief. -100.34. In the year 2010, what is the difference between the Depositors(per 1000 adults) in Rwanda and Depositors(per 1000 adults) in Venezuela?
Make the answer very short. -652.33. In the year 2010, what is the difference between the Depositors(per 1000 adults) in Tajikistan and Depositors(per 1000 adults) in Venezuela?
Your answer should be compact. -551.99. In the year 2011, what is the difference between the Depositors(per 1000 adults) in Other small states and Depositors(per 1000 adults) in Rwanda?
Offer a terse response. 196.46. In the year 2011, what is the difference between the Depositors(per 1000 adults) of Other small states and Depositors(per 1000 adults) of Tajikistan?
Provide a short and direct response. -45.53. In the year 2011, what is the difference between the Depositors(per 1000 adults) of Other small states and Depositors(per 1000 adults) of Venezuela?
Your response must be concise. -627.82. In the year 2011, what is the difference between the Depositors(per 1000 adults) in Rwanda and Depositors(per 1000 adults) in Tajikistan?
Your answer should be very brief. -241.99. In the year 2011, what is the difference between the Depositors(per 1000 adults) of Rwanda and Depositors(per 1000 adults) of Venezuela?
Your answer should be compact. -824.28. In the year 2011, what is the difference between the Depositors(per 1000 adults) of Tajikistan and Depositors(per 1000 adults) of Venezuela?
Your response must be concise. -582.29. In the year 2012, what is the difference between the Depositors(per 1000 adults) of Other small states and Depositors(per 1000 adults) of Rwanda?
Give a very brief answer. 199.8. In the year 2012, what is the difference between the Depositors(per 1000 adults) of Other small states and Depositors(per 1000 adults) of Tajikistan?
Ensure brevity in your answer.  -146.98. In the year 2012, what is the difference between the Depositors(per 1000 adults) in Other small states and Depositors(per 1000 adults) in Venezuela?
Offer a terse response. -654.63. In the year 2012, what is the difference between the Depositors(per 1000 adults) of Rwanda and Depositors(per 1000 adults) of Tajikistan?
Keep it short and to the point. -346.78. In the year 2012, what is the difference between the Depositors(per 1000 adults) in Rwanda and Depositors(per 1000 adults) in Venezuela?
Your answer should be very brief. -854.44. In the year 2012, what is the difference between the Depositors(per 1000 adults) in Tajikistan and Depositors(per 1000 adults) in Venezuela?
Give a very brief answer. -507.66. In the year 2013, what is the difference between the Depositors(per 1000 adults) of Other small states and Depositors(per 1000 adults) of Rwanda?
Provide a succinct answer. 169.22. In the year 2013, what is the difference between the Depositors(per 1000 adults) in Other small states and Depositors(per 1000 adults) in Tajikistan?
Ensure brevity in your answer.  -299.25. In the year 2013, what is the difference between the Depositors(per 1000 adults) of Other small states and Depositors(per 1000 adults) of Venezuela?
Make the answer very short. -809.21. In the year 2013, what is the difference between the Depositors(per 1000 adults) in Rwanda and Depositors(per 1000 adults) in Tajikistan?
Your answer should be very brief. -468.47. In the year 2013, what is the difference between the Depositors(per 1000 adults) of Rwanda and Depositors(per 1000 adults) of Venezuela?
Provide a short and direct response. -978.43. In the year 2013, what is the difference between the Depositors(per 1000 adults) of Tajikistan and Depositors(per 1000 adults) of Venezuela?
Keep it short and to the point. -509.96. What is the ratio of the Depositors(per 1000 adults) in Other small states in 2006 to that in 2007?
Ensure brevity in your answer.  1.81. What is the ratio of the Depositors(per 1000 adults) of Rwanda in 2006 to that in 2007?
Offer a terse response. 0.44. What is the ratio of the Depositors(per 1000 adults) in Tajikistan in 2006 to that in 2007?
Provide a short and direct response. 1.36. What is the ratio of the Depositors(per 1000 adults) in Venezuela in 2006 to that in 2007?
Keep it short and to the point. 0.88. What is the ratio of the Depositors(per 1000 adults) of Other small states in 2006 to that in 2008?
Offer a terse response. 2.21. What is the ratio of the Depositors(per 1000 adults) of Rwanda in 2006 to that in 2008?
Your answer should be very brief. 0.06. What is the ratio of the Depositors(per 1000 adults) in Tajikistan in 2006 to that in 2008?
Your answer should be compact. 1.37. What is the ratio of the Depositors(per 1000 adults) in Venezuela in 2006 to that in 2008?
Offer a very short reply. 0.82. What is the ratio of the Depositors(per 1000 adults) in Other small states in 2006 to that in 2009?
Ensure brevity in your answer.  2.03. What is the ratio of the Depositors(per 1000 adults) of Rwanda in 2006 to that in 2009?
Keep it short and to the point. 0.05. What is the ratio of the Depositors(per 1000 adults) of Tajikistan in 2006 to that in 2009?
Offer a terse response. 0.99. What is the ratio of the Depositors(per 1000 adults) in Venezuela in 2006 to that in 2009?
Your response must be concise. 0.78. What is the ratio of the Depositors(per 1000 adults) in Other small states in 2006 to that in 2010?
Provide a short and direct response. 1.94. What is the ratio of the Depositors(per 1000 adults) of Rwanda in 2006 to that in 2010?
Your answer should be very brief. 0.04. What is the ratio of the Depositors(per 1000 adults) of Tajikistan in 2006 to that in 2010?
Offer a very short reply. 0.88. What is the ratio of the Depositors(per 1000 adults) of Venezuela in 2006 to that in 2010?
Your answer should be compact. 0.65. What is the ratio of the Depositors(per 1000 adults) in Other small states in 2006 to that in 2011?
Offer a very short reply. 0.93. What is the ratio of the Depositors(per 1000 adults) of Rwanda in 2006 to that in 2011?
Offer a very short reply. 0.06. What is the ratio of the Depositors(per 1000 adults) in Tajikistan in 2006 to that in 2011?
Provide a short and direct response. 0.79. What is the ratio of the Depositors(per 1000 adults) in Venezuela in 2006 to that in 2011?
Offer a terse response. 0.6. What is the ratio of the Depositors(per 1000 adults) in Other small states in 2006 to that in 2012?
Offer a terse response. 0.84. What is the ratio of the Depositors(per 1000 adults) in Rwanda in 2006 to that in 2012?
Provide a succinct answer. 0.05. What is the ratio of the Depositors(per 1000 adults) of Tajikistan in 2006 to that in 2012?
Offer a terse response. 0.59. What is the ratio of the Depositors(per 1000 adults) in Venezuela in 2006 to that in 2012?
Make the answer very short. 0.56. What is the ratio of the Depositors(per 1000 adults) of Other small states in 2006 to that in 2013?
Your answer should be very brief. 0.84. What is the ratio of the Depositors(per 1000 adults) in Rwanda in 2006 to that in 2013?
Offer a very short reply. 0.04. What is the ratio of the Depositors(per 1000 adults) in Tajikistan in 2006 to that in 2013?
Your answer should be very brief. 0.46. What is the ratio of the Depositors(per 1000 adults) of Venezuela in 2006 to that in 2013?
Your answer should be compact. 0.49. What is the ratio of the Depositors(per 1000 adults) in Other small states in 2007 to that in 2008?
Ensure brevity in your answer.  1.22. What is the ratio of the Depositors(per 1000 adults) of Rwanda in 2007 to that in 2008?
Make the answer very short. 0.13. What is the ratio of the Depositors(per 1000 adults) of Tajikistan in 2007 to that in 2008?
Your answer should be very brief. 1.01. What is the ratio of the Depositors(per 1000 adults) of Venezuela in 2007 to that in 2008?
Ensure brevity in your answer.  0.94. What is the ratio of the Depositors(per 1000 adults) in Other small states in 2007 to that in 2009?
Your answer should be very brief. 1.12. What is the ratio of the Depositors(per 1000 adults) in Rwanda in 2007 to that in 2009?
Offer a terse response. 0.11. What is the ratio of the Depositors(per 1000 adults) of Tajikistan in 2007 to that in 2009?
Your response must be concise. 0.73. What is the ratio of the Depositors(per 1000 adults) in Venezuela in 2007 to that in 2009?
Keep it short and to the point. 0.88. What is the ratio of the Depositors(per 1000 adults) of Other small states in 2007 to that in 2010?
Provide a short and direct response. 1.07. What is the ratio of the Depositors(per 1000 adults) of Rwanda in 2007 to that in 2010?
Make the answer very short. 0.09. What is the ratio of the Depositors(per 1000 adults) of Tajikistan in 2007 to that in 2010?
Provide a short and direct response. 0.65. What is the ratio of the Depositors(per 1000 adults) in Venezuela in 2007 to that in 2010?
Offer a very short reply. 0.74. What is the ratio of the Depositors(per 1000 adults) of Other small states in 2007 to that in 2011?
Provide a succinct answer. 0.51. What is the ratio of the Depositors(per 1000 adults) in Rwanda in 2007 to that in 2011?
Provide a short and direct response. 0.14. What is the ratio of the Depositors(per 1000 adults) of Tajikistan in 2007 to that in 2011?
Provide a succinct answer. 0.58. What is the ratio of the Depositors(per 1000 adults) of Venezuela in 2007 to that in 2011?
Ensure brevity in your answer.  0.69. What is the ratio of the Depositors(per 1000 adults) in Other small states in 2007 to that in 2012?
Offer a terse response. 0.46. What is the ratio of the Depositors(per 1000 adults) in Rwanda in 2007 to that in 2012?
Provide a succinct answer. 0.12. What is the ratio of the Depositors(per 1000 adults) in Tajikistan in 2007 to that in 2012?
Provide a succinct answer. 0.43. What is the ratio of the Depositors(per 1000 adults) of Venezuela in 2007 to that in 2012?
Your answer should be very brief. 0.64. What is the ratio of the Depositors(per 1000 adults) of Other small states in 2007 to that in 2013?
Your answer should be compact. 0.46. What is the ratio of the Depositors(per 1000 adults) in Rwanda in 2007 to that in 2013?
Provide a succinct answer. 0.1. What is the ratio of the Depositors(per 1000 adults) of Tajikistan in 2007 to that in 2013?
Offer a terse response. 0.34. What is the ratio of the Depositors(per 1000 adults) in Venezuela in 2007 to that in 2013?
Your answer should be compact. 0.56. What is the ratio of the Depositors(per 1000 adults) in Other small states in 2008 to that in 2009?
Make the answer very short. 0.92. What is the ratio of the Depositors(per 1000 adults) of Rwanda in 2008 to that in 2009?
Make the answer very short. 0.87. What is the ratio of the Depositors(per 1000 adults) in Tajikistan in 2008 to that in 2009?
Provide a short and direct response. 0.72. What is the ratio of the Depositors(per 1000 adults) of Venezuela in 2008 to that in 2009?
Keep it short and to the point. 0.94. What is the ratio of the Depositors(per 1000 adults) in Other small states in 2008 to that in 2010?
Provide a short and direct response. 0.88. What is the ratio of the Depositors(per 1000 adults) in Rwanda in 2008 to that in 2010?
Your response must be concise. 0.71. What is the ratio of the Depositors(per 1000 adults) in Tajikistan in 2008 to that in 2010?
Provide a succinct answer. 0.64. What is the ratio of the Depositors(per 1000 adults) of Venezuela in 2008 to that in 2010?
Make the answer very short. 0.79. What is the ratio of the Depositors(per 1000 adults) of Other small states in 2008 to that in 2011?
Your answer should be compact. 0.42. What is the ratio of the Depositors(per 1000 adults) in Rwanda in 2008 to that in 2011?
Make the answer very short. 1.12. What is the ratio of the Depositors(per 1000 adults) of Tajikistan in 2008 to that in 2011?
Provide a succinct answer. 0.57. What is the ratio of the Depositors(per 1000 adults) in Venezuela in 2008 to that in 2011?
Your answer should be compact. 0.73. What is the ratio of the Depositors(per 1000 adults) of Other small states in 2008 to that in 2012?
Keep it short and to the point. 0.38. What is the ratio of the Depositors(per 1000 adults) of Rwanda in 2008 to that in 2012?
Keep it short and to the point. 0.93. What is the ratio of the Depositors(per 1000 adults) of Tajikistan in 2008 to that in 2012?
Make the answer very short. 0.43. What is the ratio of the Depositors(per 1000 adults) in Venezuela in 2008 to that in 2012?
Make the answer very short. 0.69. What is the ratio of the Depositors(per 1000 adults) in Other small states in 2008 to that in 2013?
Ensure brevity in your answer.  0.38. What is the ratio of the Depositors(per 1000 adults) in Rwanda in 2008 to that in 2013?
Your answer should be compact. 0.81. What is the ratio of the Depositors(per 1000 adults) in Tajikistan in 2008 to that in 2013?
Offer a terse response. 0.34. What is the ratio of the Depositors(per 1000 adults) in Venezuela in 2008 to that in 2013?
Provide a short and direct response. 0.6. What is the ratio of the Depositors(per 1000 adults) in Other small states in 2009 to that in 2010?
Make the answer very short. 0.95. What is the ratio of the Depositors(per 1000 adults) of Rwanda in 2009 to that in 2010?
Provide a succinct answer. 0.81. What is the ratio of the Depositors(per 1000 adults) of Tajikistan in 2009 to that in 2010?
Provide a short and direct response. 0.89. What is the ratio of the Depositors(per 1000 adults) in Venezuela in 2009 to that in 2010?
Your answer should be very brief. 0.84. What is the ratio of the Depositors(per 1000 adults) of Other small states in 2009 to that in 2011?
Your response must be concise. 0.46. What is the ratio of the Depositors(per 1000 adults) in Rwanda in 2009 to that in 2011?
Offer a terse response. 1.29. What is the ratio of the Depositors(per 1000 adults) of Tajikistan in 2009 to that in 2011?
Provide a short and direct response. 0.79. What is the ratio of the Depositors(per 1000 adults) of Venezuela in 2009 to that in 2011?
Make the answer very short. 0.78. What is the ratio of the Depositors(per 1000 adults) of Other small states in 2009 to that in 2012?
Offer a very short reply. 0.41. What is the ratio of the Depositors(per 1000 adults) of Rwanda in 2009 to that in 2012?
Make the answer very short. 1.06. What is the ratio of the Depositors(per 1000 adults) in Tajikistan in 2009 to that in 2012?
Your answer should be very brief. 0.59. What is the ratio of the Depositors(per 1000 adults) of Venezuela in 2009 to that in 2012?
Your answer should be compact. 0.73. What is the ratio of the Depositors(per 1000 adults) in Other small states in 2009 to that in 2013?
Provide a succinct answer. 0.41. What is the ratio of the Depositors(per 1000 adults) in Rwanda in 2009 to that in 2013?
Your response must be concise. 0.93. What is the ratio of the Depositors(per 1000 adults) of Tajikistan in 2009 to that in 2013?
Make the answer very short. 0.46. What is the ratio of the Depositors(per 1000 adults) in Venezuela in 2009 to that in 2013?
Your answer should be very brief. 0.64. What is the ratio of the Depositors(per 1000 adults) in Other small states in 2010 to that in 2011?
Provide a short and direct response. 0.48. What is the ratio of the Depositors(per 1000 adults) of Rwanda in 2010 to that in 2011?
Offer a terse response. 1.58. What is the ratio of the Depositors(per 1000 adults) of Tajikistan in 2010 to that in 2011?
Offer a very short reply. 0.89. What is the ratio of the Depositors(per 1000 adults) in Venezuela in 2010 to that in 2011?
Make the answer very short. 0.93. What is the ratio of the Depositors(per 1000 adults) in Other small states in 2010 to that in 2012?
Your answer should be very brief. 0.43. What is the ratio of the Depositors(per 1000 adults) of Rwanda in 2010 to that in 2012?
Your response must be concise. 1.3. What is the ratio of the Depositors(per 1000 adults) of Tajikistan in 2010 to that in 2012?
Ensure brevity in your answer.  0.67. What is the ratio of the Depositors(per 1000 adults) of Venezuela in 2010 to that in 2012?
Your response must be concise. 0.87. What is the ratio of the Depositors(per 1000 adults) of Other small states in 2010 to that in 2013?
Your answer should be very brief. 0.43. What is the ratio of the Depositors(per 1000 adults) in Rwanda in 2010 to that in 2013?
Provide a short and direct response. 1.14. What is the ratio of the Depositors(per 1000 adults) in Tajikistan in 2010 to that in 2013?
Your response must be concise. 0.52. What is the ratio of the Depositors(per 1000 adults) in Venezuela in 2010 to that in 2013?
Ensure brevity in your answer.  0.76. What is the ratio of the Depositors(per 1000 adults) in Other small states in 2011 to that in 2012?
Give a very brief answer. 0.9. What is the ratio of the Depositors(per 1000 adults) of Rwanda in 2011 to that in 2012?
Your response must be concise. 0.82. What is the ratio of the Depositors(per 1000 adults) in Tajikistan in 2011 to that in 2012?
Provide a short and direct response. 0.74. What is the ratio of the Depositors(per 1000 adults) of Venezuela in 2011 to that in 2012?
Your answer should be very brief. 0.94. What is the ratio of the Depositors(per 1000 adults) of Other small states in 2011 to that in 2013?
Your answer should be compact. 0.9. What is the ratio of the Depositors(per 1000 adults) in Rwanda in 2011 to that in 2013?
Provide a short and direct response. 0.72. What is the ratio of the Depositors(per 1000 adults) of Tajikistan in 2011 to that in 2013?
Ensure brevity in your answer.  0.58. What is the ratio of the Depositors(per 1000 adults) of Venezuela in 2011 to that in 2013?
Give a very brief answer. 0.82. What is the ratio of the Depositors(per 1000 adults) in Other small states in 2012 to that in 2013?
Ensure brevity in your answer.  1. What is the ratio of the Depositors(per 1000 adults) in Rwanda in 2012 to that in 2013?
Ensure brevity in your answer.  0.87. What is the ratio of the Depositors(per 1000 adults) in Tajikistan in 2012 to that in 2013?
Make the answer very short. 0.78. What is the ratio of the Depositors(per 1000 adults) in Venezuela in 2012 to that in 2013?
Ensure brevity in your answer.  0.87. What is the difference between the highest and the second highest Depositors(per 1000 adults) of Other small states?
Ensure brevity in your answer.  0.38. What is the difference between the highest and the second highest Depositors(per 1000 adults) of Rwanda?
Provide a short and direct response. 32.04. What is the difference between the highest and the second highest Depositors(per 1000 adults) of Tajikistan?
Provide a succinct answer. 151.9. What is the difference between the highest and the second highest Depositors(per 1000 adults) in Venezuela?
Give a very brief answer. 154.19. What is the difference between the highest and the lowest Depositors(per 1000 adults) in Other small states?
Make the answer very short. 250.91. What is the difference between the highest and the lowest Depositors(per 1000 adults) in Rwanda?
Keep it short and to the point. 256.03. What is the difference between the highest and the lowest Depositors(per 1000 adults) of Tajikistan?
Your response must be concise. 467.06. What is the difference between the highest and the lowest Depositors(per 1000 adults) in Venezuela?
Keep it short and to the point. 615.75. 